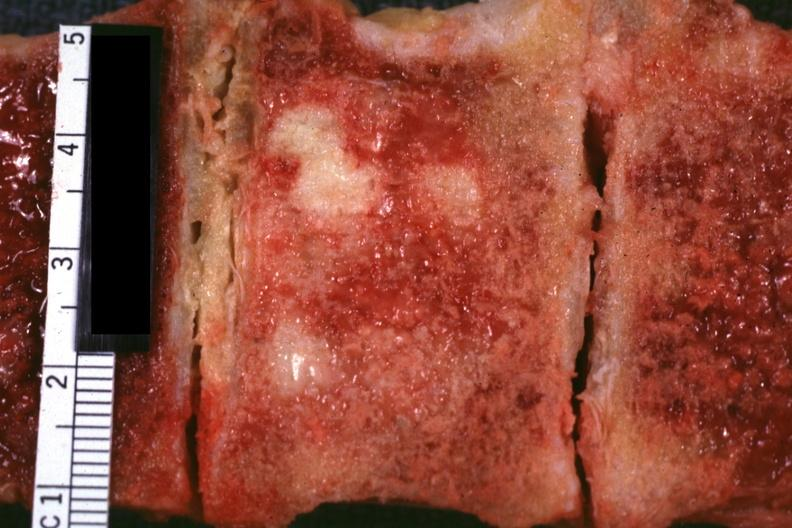what does this image show?
Answer the question using a single word or phrase. Very close-up view excellent vertebral body primary is prostate adenocarcinoma 